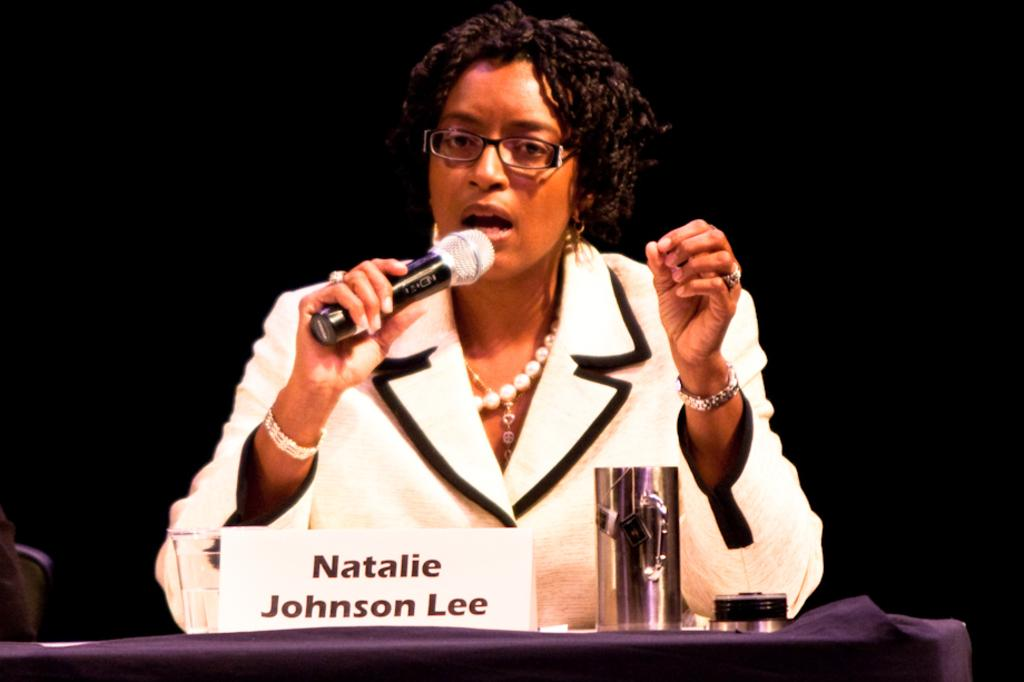Who is the main subject in the image? There is a woman in the image. What is the woman doing in the image? The woman is talking on a microphone. Can you describe the woman's appearance? The woman is wearing spectacles. What else can be seen in the image? There is a table and a glass on the table. What type of bird is sitting on the woman's shoulder in the image? There is no bird present in the image. Can you tell me how much coal is on the table in the image? There is no coal present in the image; only a glass can be seen on the table. 